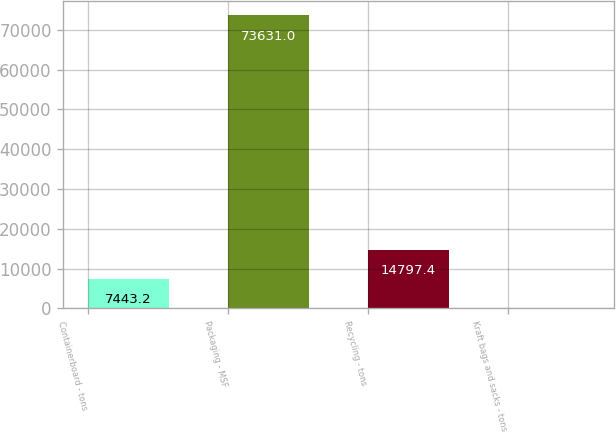Convert chart. <chart><loc_0><loc_0><loc_500><loc_500><bar_chart><fcel>Containerboard - tons<fcel>Packaging - MSF<fcel>Recycling - tons<fcel>Kraft bags and sacks - tons<nl><fcel>7443.2<fcel>73631<fcel>14797.4<fcel>89<nl></chart> 